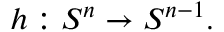Convert formula to latex. <formula><loc_0><loc_0><loc_500><loc_500>h \colon S ^ { n } \to S ^ { n - 1 } .</formula> 